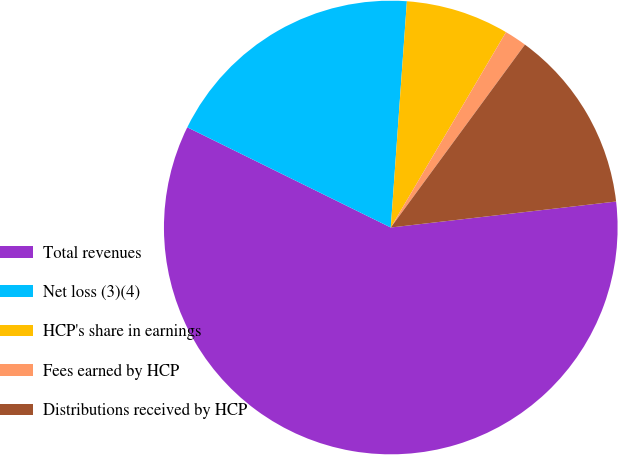Convert chart. <chart><loc_0><loc_0><loc_500><loc_500><pie_chart><fcel>Total revenues<fcel>Net loss (3)(4)<fcel>HCP's share in earnings<fcel>Fees earned by HCP<fcel>Distributions received by HCP<nl><fcel>59.11%<fcel>18.85%<fcel>7.35%<fcel>1.59%<fcel>13.1%<nl></chart> 